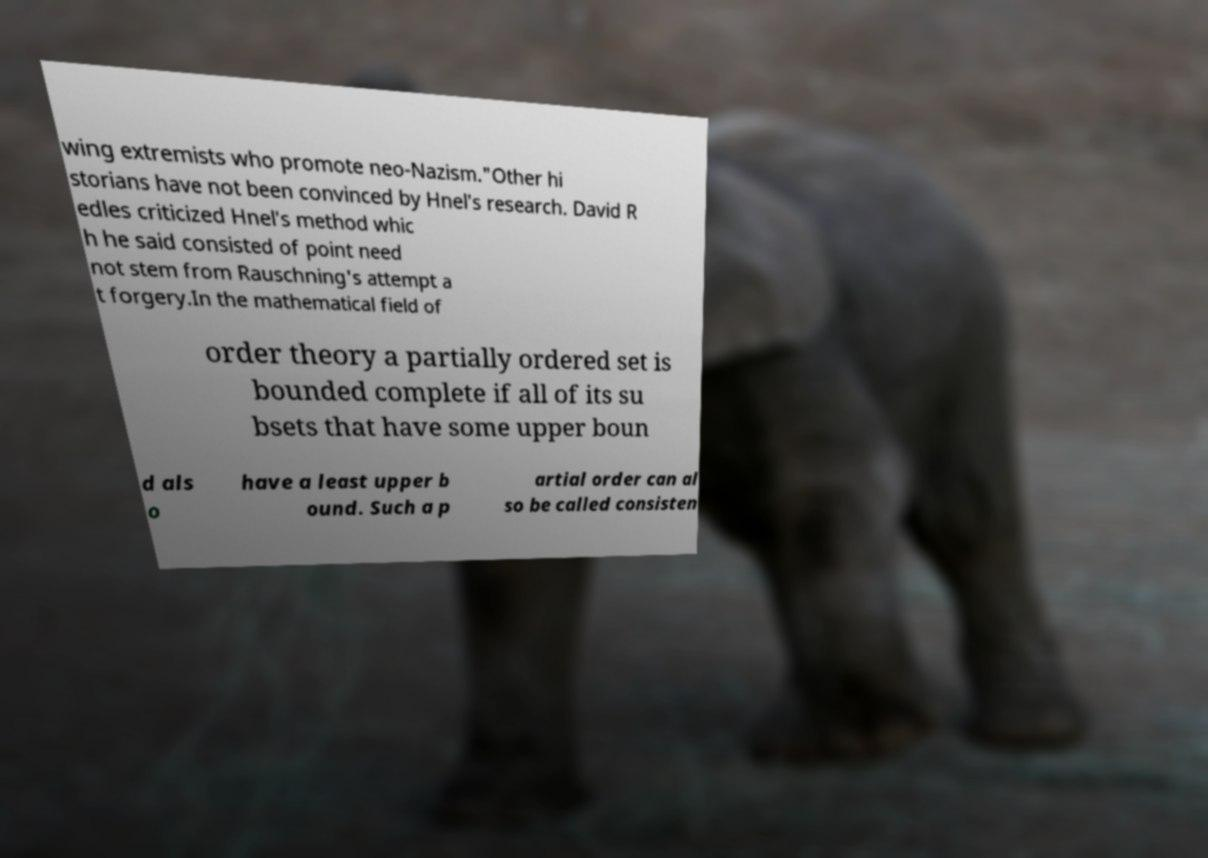Can you read and provide the text displayed in the image?This photo seems to have some interesting text. Can you extract and type it out for me? wing extremists who promote neo-Nazism."Other hi storians have not been convinced by Hnel′s research. David R edles criticized Hnel′s method whic h he said consisted of point need not stem from Rauschning's attempt a t forgery.In the mathematical field of order theory a partially ordered set is bounded complete if all of its su bsets that have some upper boun d als o have a least upper b ound. Such a p artial order can al so be called consisten 